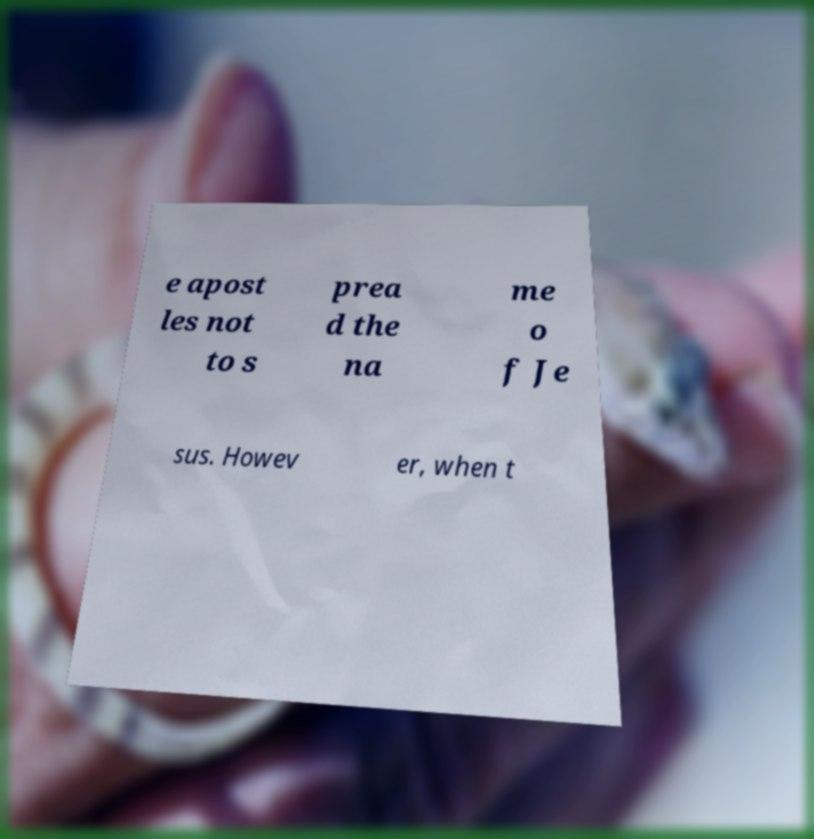I need the written content from this picture converted into text. Can you do that? e apost les not to s prea d the na me o f Je sus. Howev er, when t 